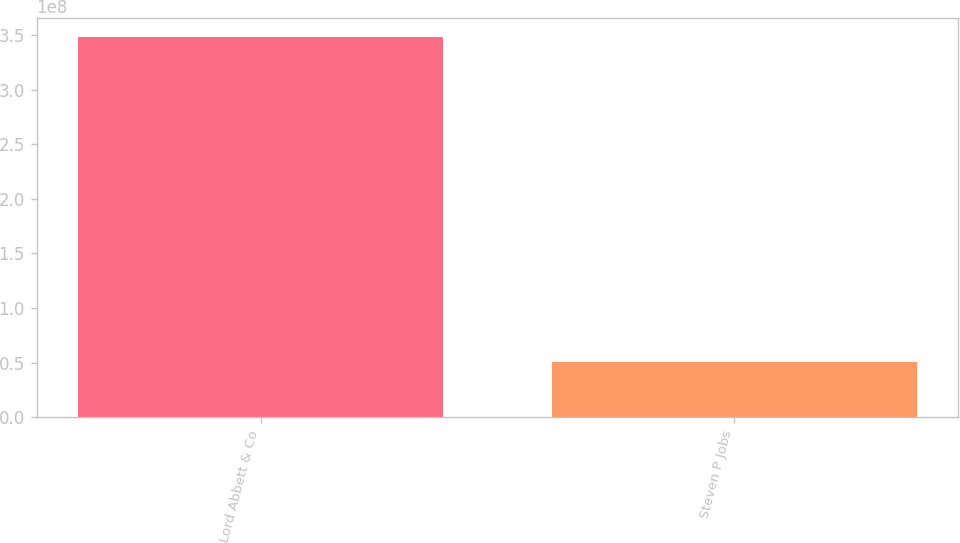Convert chart to OTSL. <chart><loc_0><loc_0><loc_500><loc_500><bar_chart><fcel>Lord Abbett & Co<fcel>Steven P Jobs<nl><fcel>3.48642e+08<fcel>5.06e+07<nl></chart> 